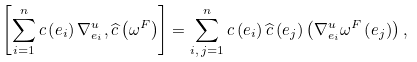Convert formula to latex. <formula><loc_0><loc_0><loc_500><loc_500>\left [ \sum _ { i = 1 } ^ { n } c \left ( e _ { i } \right ) \nabla _ { e _ { i } } ^ { u } , \widehat { c } \left ( \omega ^ { F } \right ) \right ] = \sum _ { i , \, j = 1 } ^ { n } c \left ( e _ { i } \right ) \widehat { c } \left ( e _ { j } \right ) \left ( \nabla _ { e _ { i } } ^ { u } \omega ^ { F } \left ( e _ { j } \right ) \right ) ,</formula> 